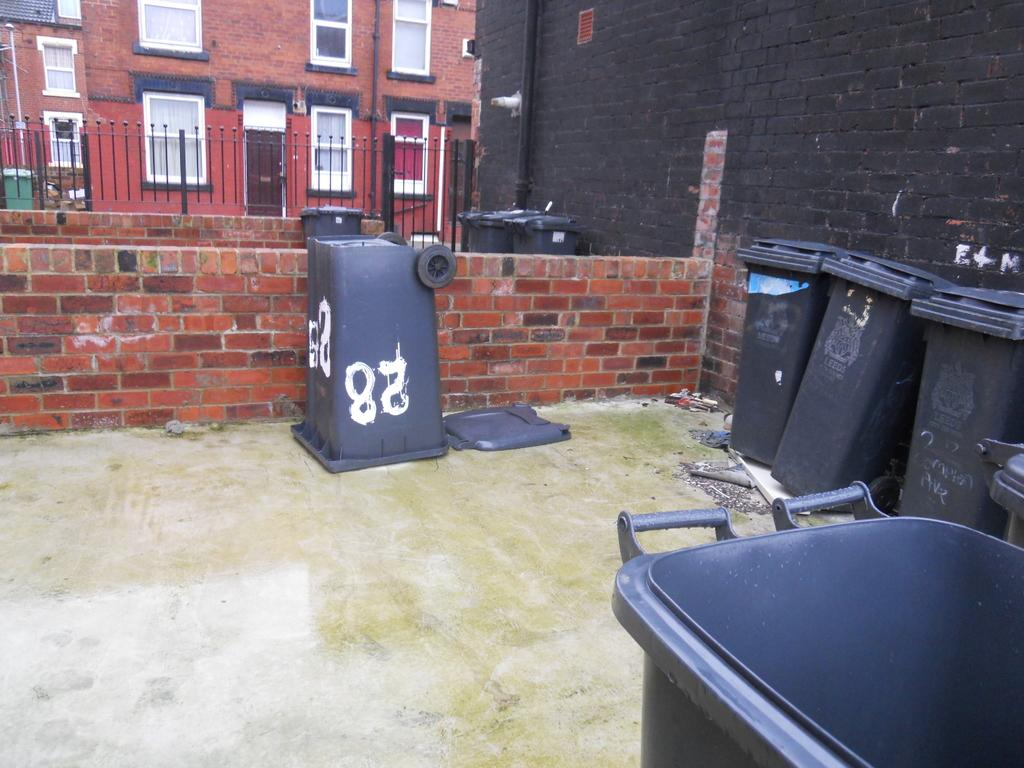<image>
Render a clear and concise summary of the photo. A garbage bin is upside down and gas the number 28 on it. 